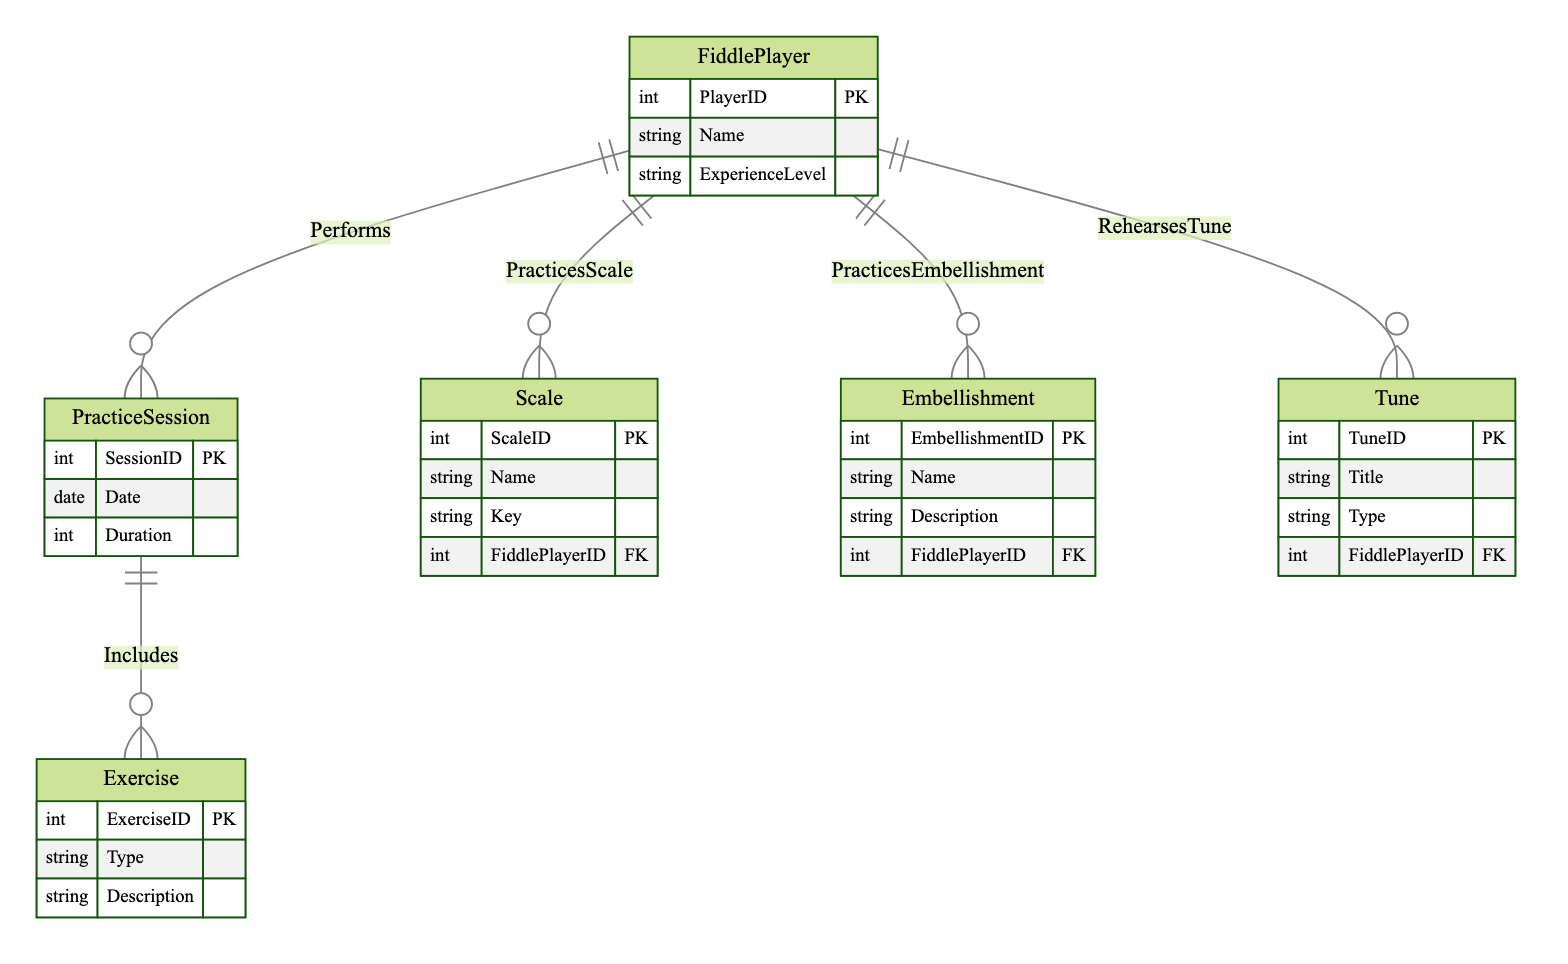What is the primary entity that represents a player of the fiddle? The diagram shows the structure of the entities, with the "FiddlePlayer" entity being defined as the main entity, indicating that it represents the player.
Answer: FiddlePlayer How many types of exercises are specified in the diagram? The "Exercise" entity has one type attribute, but the specific exercises are not detailed. However, based on context, there are multiple exercise types like scales and embellishments which are classified separately. Thus, the counting involves connecting the entities accordingly.
Answer: 3 What is the maximum number of practice sessions a fiddle player can perform? Each fiddle player can have multiple practice sessions, as indicated by the "Performs" relationship which connects "FiddlePlayer" to "PracticeSession". There is no explicit limit defined in the diagram.
Answer: Unlimited Which entity includes the description of various exercises? The "Exercise" entity includes the attribute "Description", making it clear that this entity contains information about the exercises.
Answer: Exercise What is the relationship name that connects a fiddle player to their practice sessions? The diagram clearly identifies the relationship between "FiddlePlayer" and "PracticeSession" as "Performs". This name signifies the action taken by the player with respect to the practice sessions.
Answer: Performs How many relationships connect the FiddlePlayer entity to other entities? Counting the relationships stemming from "FiddlePlayer", we have "Performs", "PracticesScale", "PracticesEmbellishment", and "RehearsesTune", which totals four distinct relationships.
Answer: 4 What kind of exercises can be included in a practice session? The "Includes" relationship stating that "PracticeSession" can have various "Exercise" types, indicates scales, embellishments, and possibly other unspecified exercises are included.
Answer: Various Which entity provides the title of the tunes being rehearsed? The "Tune" entity contains the attribute "Title", meaning that this entity is responsible for holding the title information of the tunes that the player rehearses.
Answer: Tune What is the key attribute type for the Scale entity? The "Scale" entity contains attributes such as "ScaleID", "Name", "Key", and "FiddlePlayerID", indicating that "FiddlePlayerID" serves as the foreign key related to the fiddle player entity.
Answer: FiddlePlayerID 